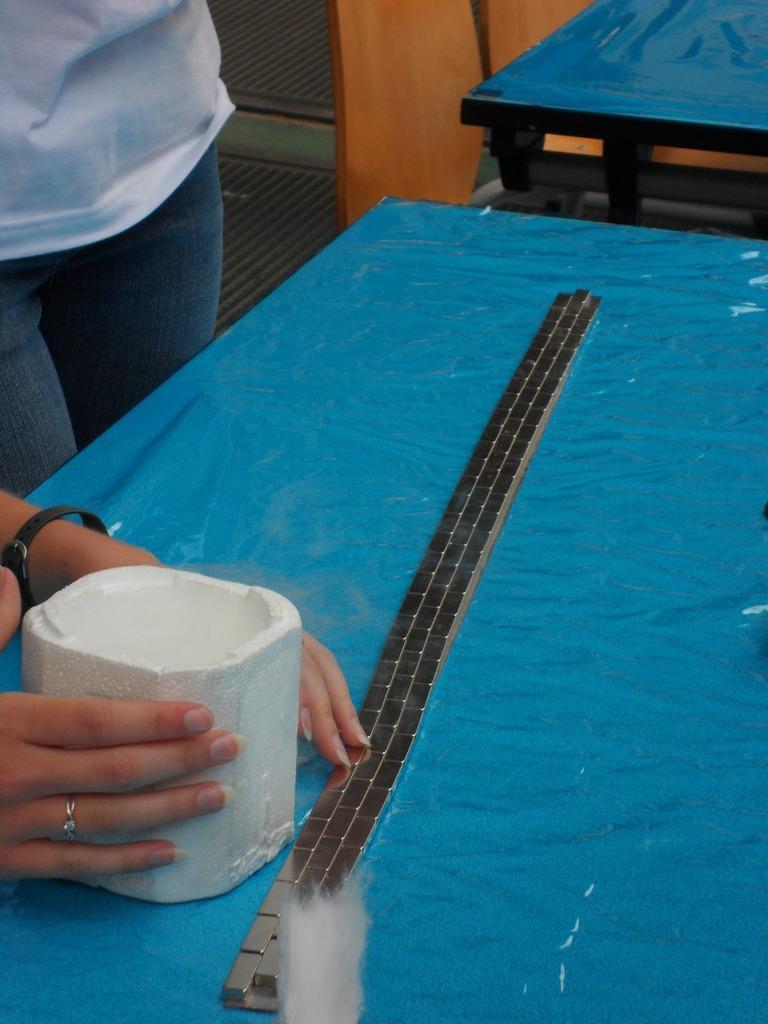Describe this image in one or two sentences. This picture shows a table and a woman hands on the table 